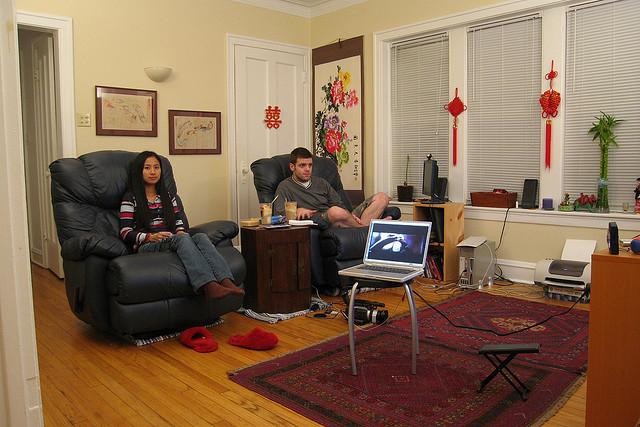What is the color of the ladies vest?
Concise answer only. Black. Is the lady sitting in a recliner?
Keep it brief. Yes. How many people are here?
Be succinct. 2. Are either of these two people looking at the computer screen shown?
Short answer required. No. They have carpet in this room?
Quick response, please. No. Are they in a library?
Give a very brief answer. No. Is there a fireplace on the picture?
Concise answer only. No. How many mugs are on the table?
Keep it brief. 2. Are the blinds closed?
Be succinct. Yes. Are there cushions on the chairs?
Write a very short answer. Yes. How many chairs in the picture?
Concise answer only. 2. Where is the woman?
Write a very short answer. In chair. Is the person outdoors?
Give a very brief answer. No. What is the color of the child's pants?
Write a very short answer. Blue. What are the persons feet on?
Give a very brief answer. Chair. What's the blue thing on the chair for?
Write a very short answer. Comfort. Is the woman moving?
Write a very short answer. No. Does this family have a child?
Quick response, please. No. 